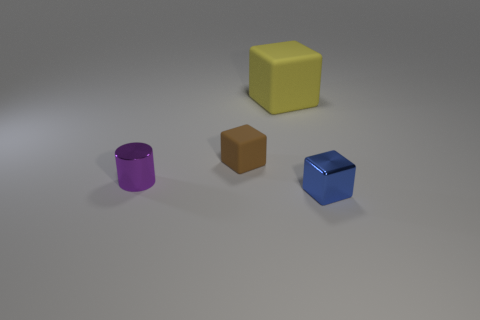Add 4 large purple things. How many objects exist? 8 Subtract all cylinders. How many objects are left? 3 Add 1 blue things. How many blue things exist? 2 Subtract 0 gray blocks. How many objects are left? 4 Subtract all small metallic cubes. Subtract all tiny purple things. How many objects are left? 2 Add 4 large yellow objects. How many large yellow objects are left? 5 